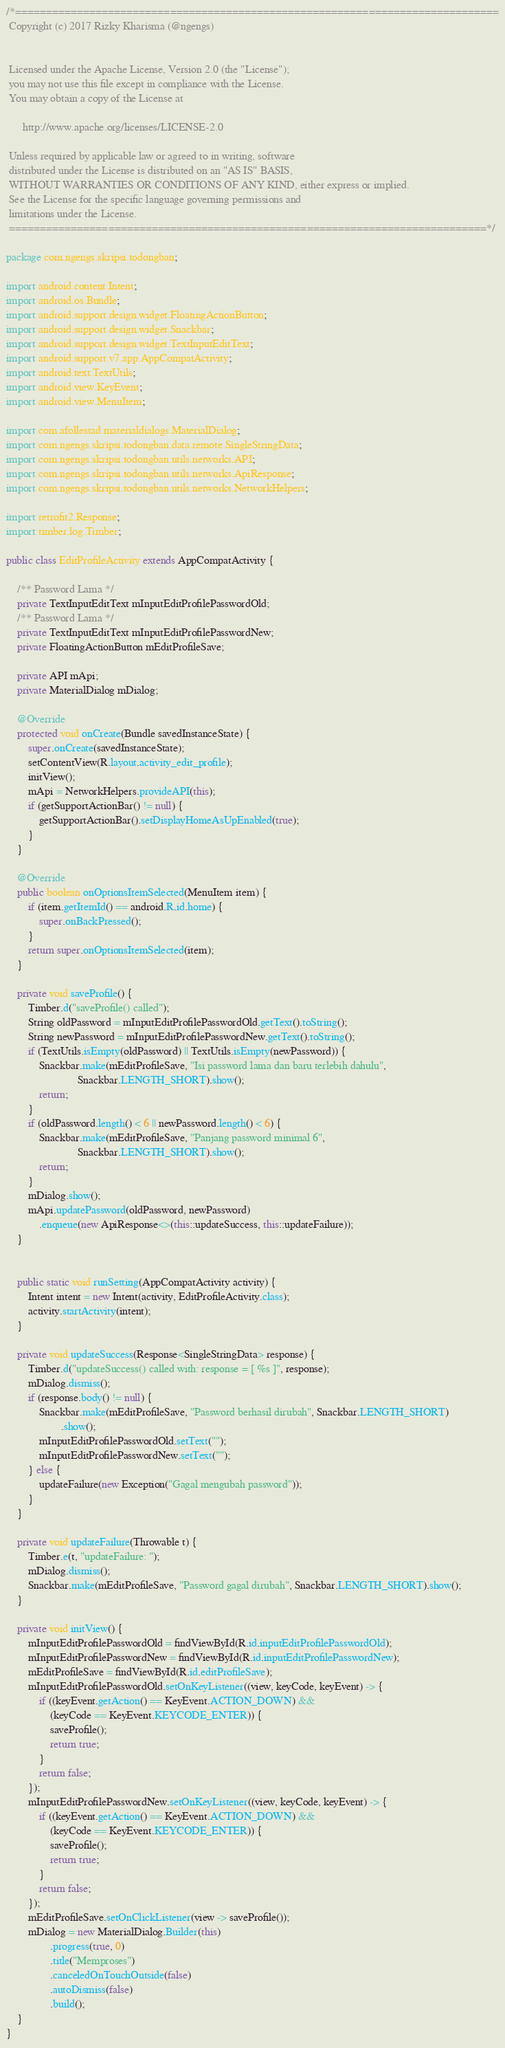Convert code to text. <code><loc_0><loc_0><loc_500><loc_500><_Java_>/*==============================================================================
 Copyright (c) 2017 Rizky Kharisma (@ngengs)


 Licensed under the Apache License, Version 2.0 (the "License");
 you may not use this file except in compliance with the License.
 You may obtain a copy of the License at

      http://www.apache.org/licenses/LICENSE-2.0

 Unless required by applicable law or agreed to in writing, software
 distributed under the License is distributed on an "AS IS" BASIS,
 WITHOUT WARRANTIES OR CONDITIONS OF ANY KIND, either express or implied.
 See the License for the specific language governing permissions and
 limitations under the License.
 =============================================================================*/

package com.ngengs.skripsi.todongban;

import android.content.Intent;
import android.os.Bundle;
import android.support.design.widget.FloatingActionButton;
import android.support.design.widget.Snackbar;
import android.support.design.widget.TextInputEditText;
import android.support.v7.app.AppCompatActivity;
import android.text.TextUtils;
import android.view.KeyEvent;
import android.view.MenuItem;

import com.afollestad.materialdialogs.MaterialDialog;
import com.ngengs.skripsi.todongban.data.remote.SingleStringData;
import com.ngengs.skripsi.todongban.utils.networks.API;
import com.ngengs.skripsi.todongban.utils.networks.ApiResponse;
import com.ngengs.skripsi.todongban.utils.networks.NetworkHelpers;

import retrofit2.Response;
import timber.log.Timber;

public class EditProfileActivity extends AppCompatActivity {

    /** Password Lama */
    private TextInputEditText mInputEditProfilePasswordOld;
    /** Password Lama */
    private TextInputEditText mInputEditProfilePasswordNew;
    private FloatingActionButton mEditProfileSave;

    private API mApi;
    private MaterialDialog mDialog;

    @Override
    protected void onCreate(Bundle savedInstanceState) {
        super.onCreate(savedInstanceState);
        setContentView(R.layout.activity_edit_profile);
        initView();
        mApi = NetworkHelpers.provideAPI(this);
        if (getSupportActionBar() != null) {
            getSupportActionBar().setDisplayHomeAsUpEnabled(true);
        }
    }

    @Override
    public boolean onOptionsItemSelected(MenuItem item) {
        if (item.getItemId() == android.R.id.home) {
            super.onBackPressed();
        }
        return super.onOptionsItemSelected(item);
    }

    private void saveProfile() {
        Timber.d("saveProfile() called");
        String oldPassword = mInputEditProfilePasswordOld.getText().toString();
        String newPassword = mInputEditProfilePasswordNew.getText().toString();
        if (TextUtils.isEmpty(oldPassword) || TextUtils.isEmpty(newPassword)) {
            Snackbar.make(mEditProfileSave, "Isi password lama dan baru terlebih dahulu",
                          Snackbar.LENGTH_SHORT).show();
            return;
        }
        if (oldPassword.length() < 6 || newPassword.length() < 6) {
            Snackbar.make(mEditProfileSave, "Panjang password minimal 6",
                          Snackbar.LENGTH_SHORT).show();
            return;
        }
        mDialog.show();
        mApi.updatePassword(oldPassword, newPassword)
            .enqueue(new ApiResponse<>(this::updateSuccess, this::updateFailure));
    }


    public static void runSetting(AppCompatActivity activity) {
        Intent intent = new Intent(activity, EditProfileActivity.class);
        activity.startActivity(intent);
    }

    private void updateSuccess(Response<SingleStringData> response) {
        Timber.d("updateSuccess() called with: response = [ %s ]", response);
        mDialog.dismiss();
        if (response.body() != null) {
            Snackbar.make(mEditProfileSave, "Password berhasil dirubah", Snackbar.LENGTH_SHORT)
                    .show();
            mInputEditProfilePasswordOld.setText("");
            mInputEditProfilePasswordNew.setText("");
        } else {
            updateFailure(new Exception("Gagal mengubah password"));
        }
    }

    private void updateFailure(Throwable t) {
        Timber.e(t, "updateFailure: ");
        mDialog.dismiss();
        Snackbar.make(mEditProfileSave, "Password gagal dirubah", Snackbar.LENGTH_SHORT).show();
    }

    private void initView() {
        mInputEditProfilePasswordOld = findViewById(R.id.inputEditProfilePasswordOld);
        mInputEditProfilePasswordNew = findViewById(R.id.inputEditProfilePasswordNew);
        mEditProfileSave = findViewById(R.id.editProfileSave);
        mInputEditProfilePasswordOld.setOnKeyListener((view, keyCode, keyEvent) -> {
            if ((keyEvent.getAction() == KeyEvent.ACTION_DOWN) &&
                (keyCode == KeyEvent.KEYCODE_ENTER)) {
                saveProfile();
                return true;
            }
            return false;
        });
        mInputEditProfilePasswordNew.setOnKeyListener((view, keyCode, keyEvent) -> {
            if ((keyEvent.getAction() == KeyEvent.ACTION_DOWN) &&
                (keyCode == KeyEvent.KEYCODE_ENTER)) {
                saveProfile();
                return true;
            }
            return false;
        });
        mEditProfileSave.setOnClickListener(view -> saveProfile());
        mDialog = new MaterialDialog.Builder(this)
                .progress(true, 0)
                .title("Memproses")
                .canceledOnTouchOutside(false)
                .autoDismiss(false)
                .build();
    }
}
</code> 